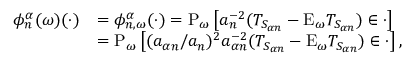Convert formula to latex. <formula><loc_0><loc_0><loc_500><loc_500>\begin{array} { r l } { \phi _ { n } ^ { \alpha } ( \omega ) ( \cdot ) } & { = \phi _ { n , \omega } ^ { \alpha } ( \cdot ) = P _ { \omega } \left [ a _ { n } ^ { - 2 } ( T _ { S _ { \alpha n } } - E _ { \omega } T _ { S _ { \alpha n } } ) \in \cdot \right ] } \\ & { = P _ { \omega } \left [ ( a _ { \alpha n } / a _ { n } ) ^ { 2 } a _ { \alpha n } ^ { - 2 } ( T _ { S _ { \alpha n } } - E _ { \omega } T _ { S _ { \alpha n } } ) \in \cdot \right ] , } \end{array}</formula> 